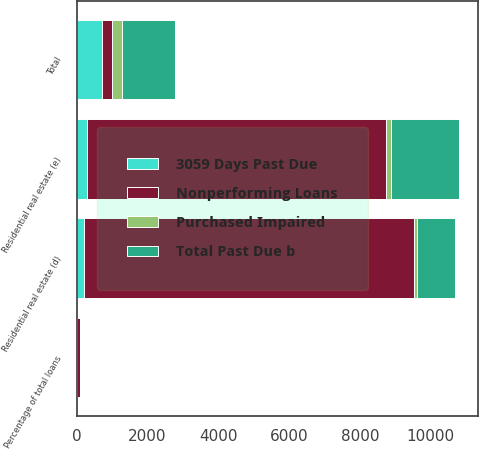Convert chart to OTSL. <chart><loc_0><loc_0><loc_500><loc_500><stacked_bar_chart><ecel><fcel>Residential real estate (d)<fcel>Total<fcel>Percentage of total loans<fcel>Residential real estate (e)<nl><fcel>Nonperforming Loans<fcel>9311<fcel>278<fcel>93.83<fcel>8464<nl><fcel>3059 Days Past Due<fcel>217<fcel>714<fcel>0.37<fcel>278<nl><fcel>Purchased Impaired<fcel>87<fcel>285<fcel>0.15<fcel>146<nl><fcel>Total Past Due b<fcel>1060<fcel>1491<fcel>0.76<fcel>1901<nl></chart> 